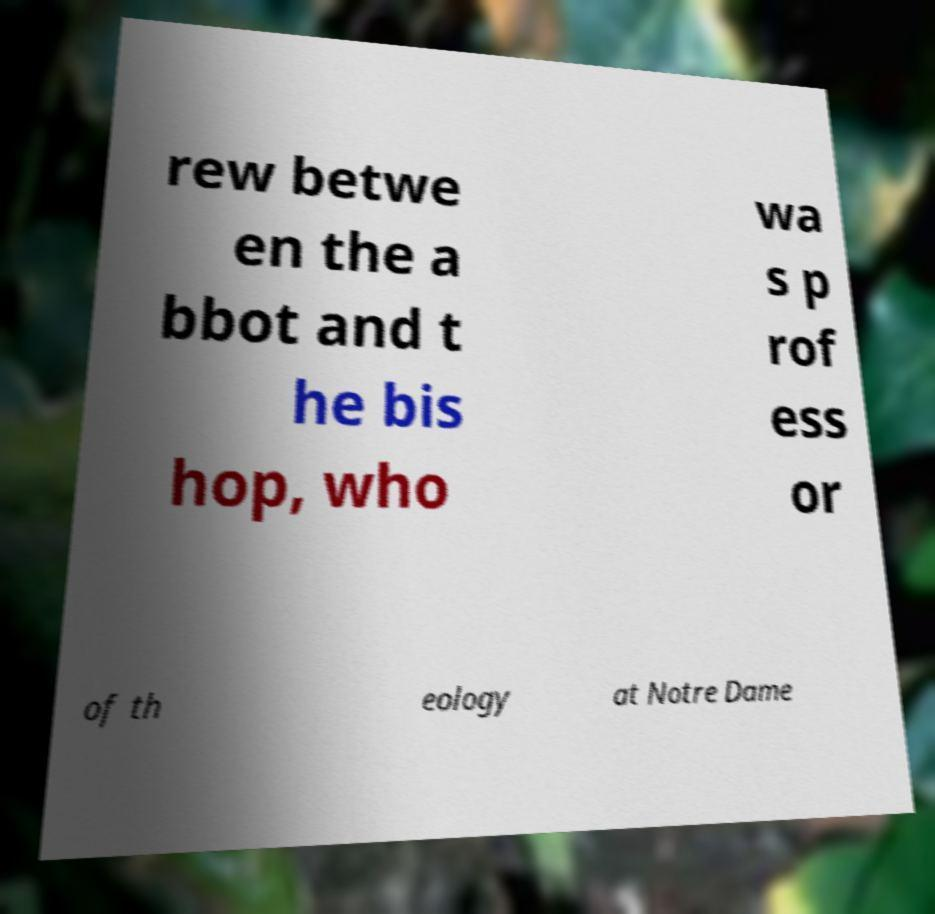For documentation purposes, I need the text within this image transcribed. Could you provide that? rew betwe en the a bbot and t he bis hop, who wa s p rof ess or of th eology at Notre Dame 